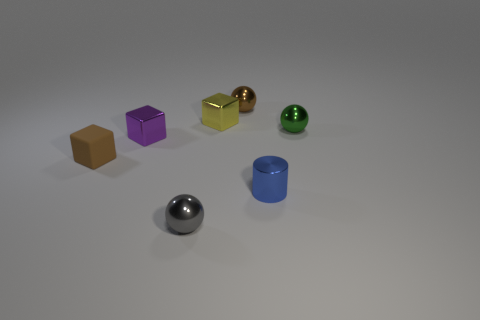Add 3 yellow objects. How many objects exist? 10 Subtract all cylinders. How many objects are left? 6 Add 4 brown blocks. How many brown blocks exist? 5 Subtract 1 brown balls. How many objects are left? 6 Subtract all tiny brown rubber spheres. Subtract all yellow metal blocks. How many objects are left? 6 Add 7 gray spheres. How many gray spheres are left? 8 